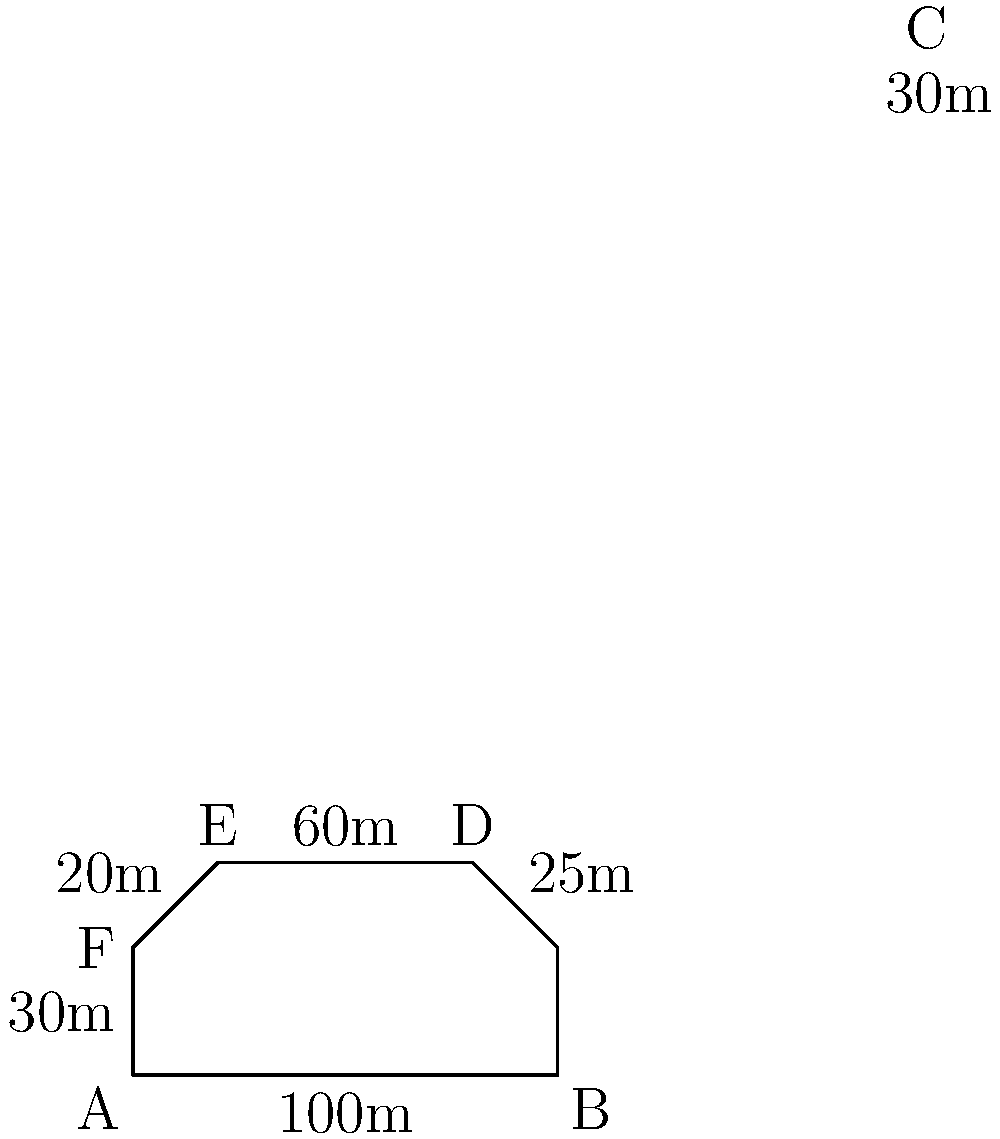As you reminisce about the glorious matches at Anfield, you recall its unique shape. The stadium's outline forms an irregular hexagon, as shown in the diagram. If the lengths of the sides are as indicated, what is the perimeter of Anfield stadium? To calculate the perimeter of Anfield stadium, we need to sum up the lengths of all sides of the irregular hexagon:

1. Side AB: 100m
2. Side BC: 30m
3. Side CD: 25m
4. Side DE: 60m
5. Side EF: 20m
6. Side FA: 30m

Now, let's add all these lengths together:

$$\text{Perimeter} = 100 + 30 + 25 + 60 + 20 + 30 = 265\text{ m}$$

Therefore, the perimeter of Anfield stadium, based on this representation, is 265 meters.
Answer: 265 m 